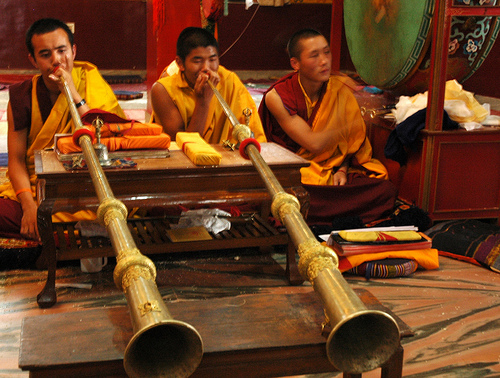<image>
Can you confirm if the trumpet is on the table? Yes. Looking at the image, I can see the trumpet is positioned on top of the table, with the table providing support. Is the steamer next to the water? No. The steamer is not positioned next to the water. They are located in different areas of the scene. 